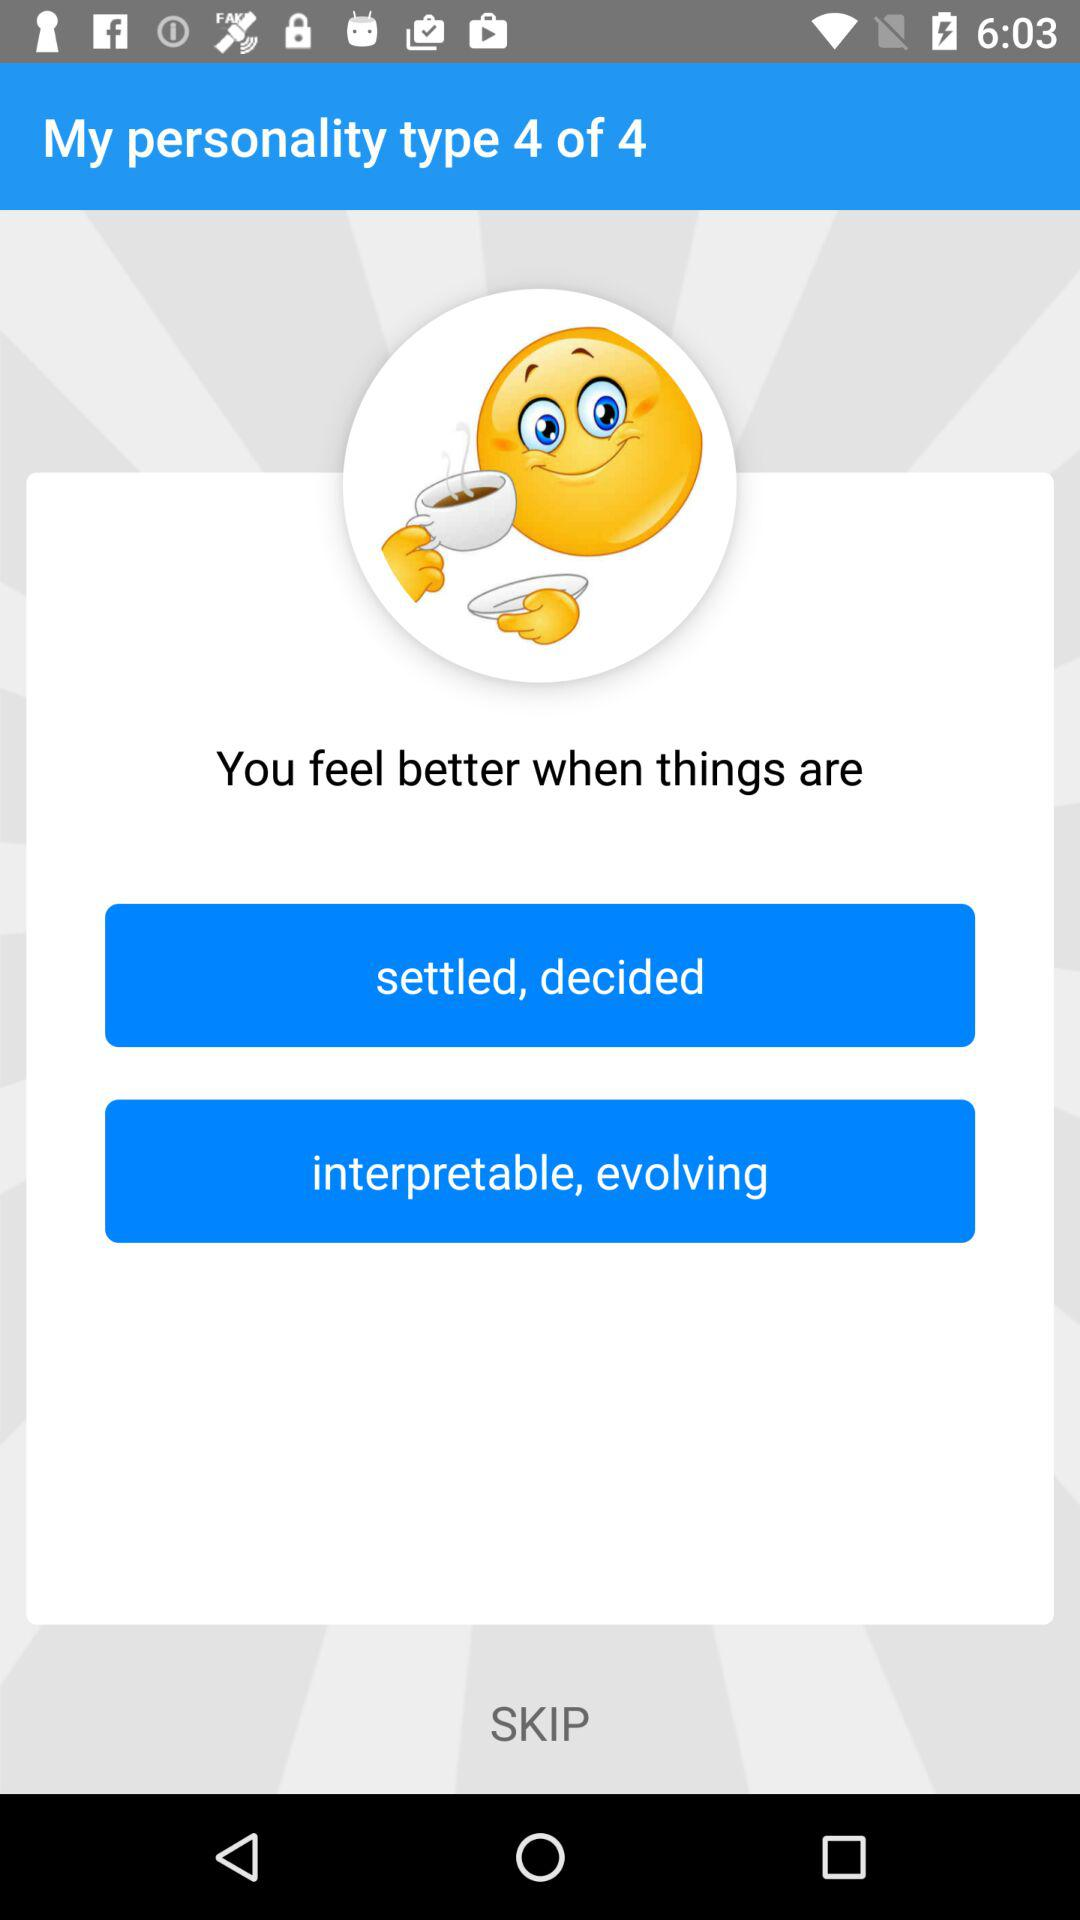How many personality types are there?
When the provided information is insufficient, respond with <no answer>. <no answer> 